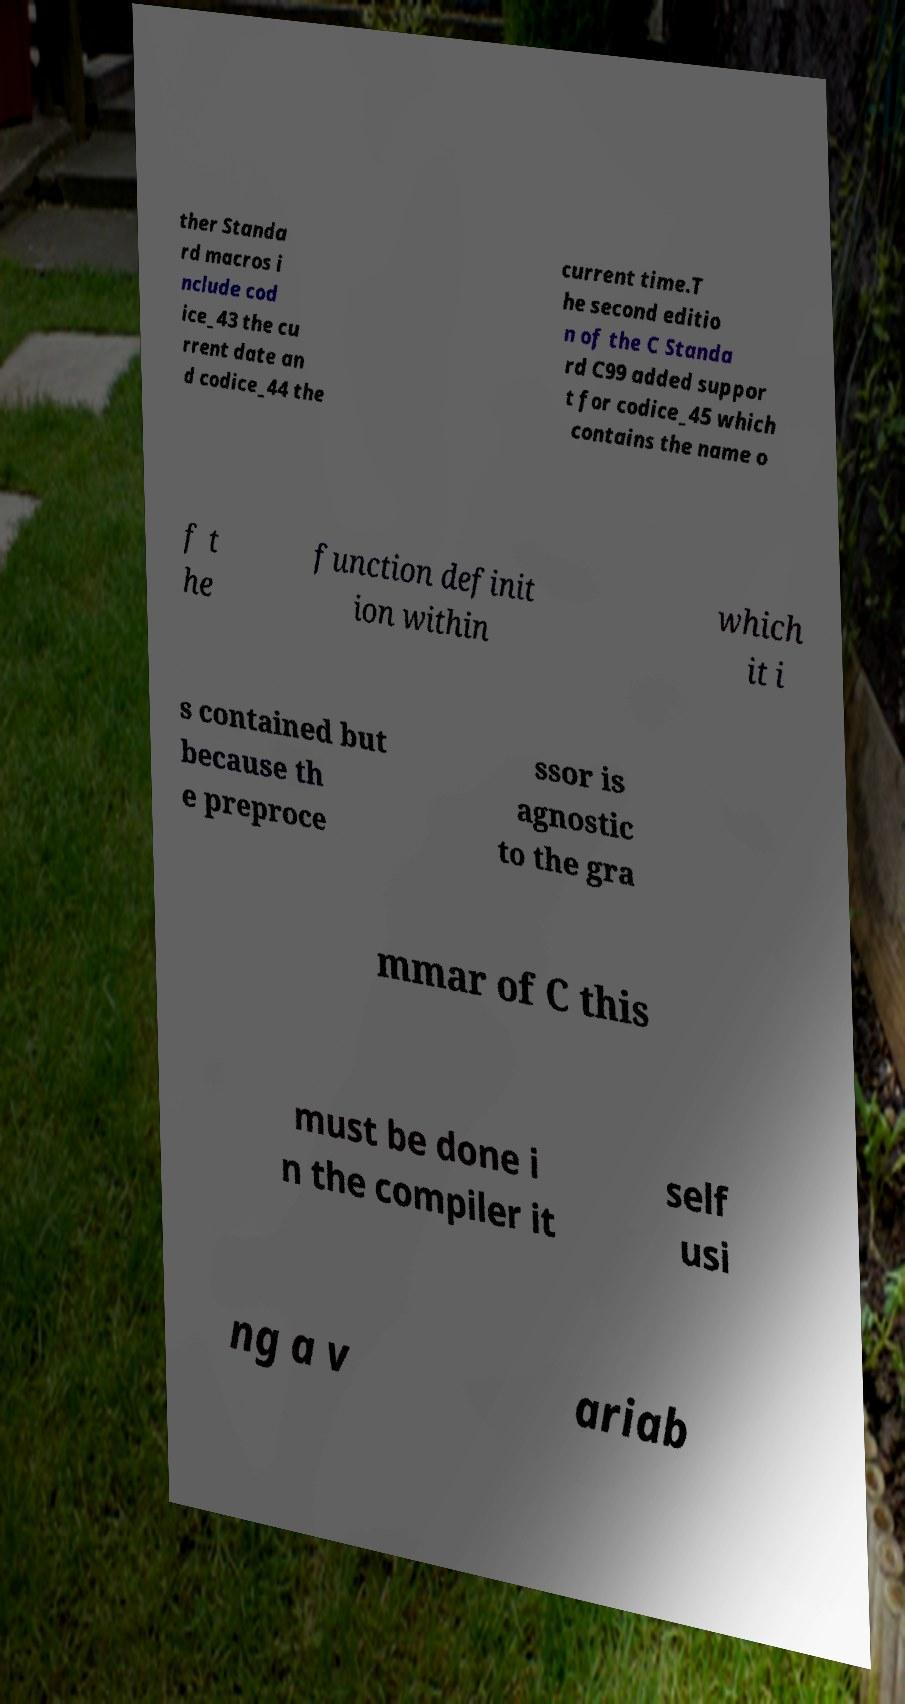For documentation purposes, I need the text within this image transcribed. Could you provide that? ther Standa rd macros i nclude cod ice_43 the cu rrent date an d codice_44 the current time.T he second editio n of the C Standa rd C99 added suppor t for codice_45 which contains the name o f t he function definit ion within which it i s contained but because th e preproce ssor is agnostic to the gra mmar of C this must be done i n the compiler it self usi ng a v ariab 